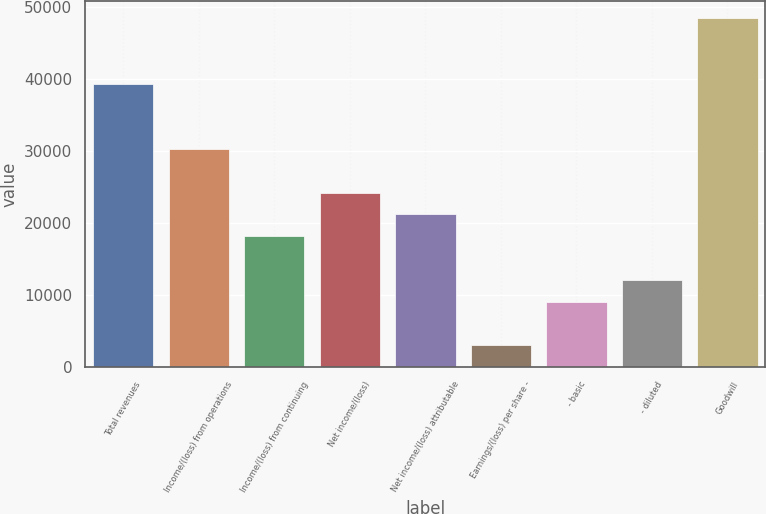Convert chart to OTSL. <chart><loc_0><loc_0><loc_500><loc_500><bar_chart><fcel>Total revenues<fcel>Income/(loss) from operations<fcel>Income/(loss) from continuing<fcel>Net income/(loss)<fcel>Net income/(loss) attributable<fcel>Earnings/(loss) per share -<fcel>- basic<fcel>- diluted<fcel>Goodwill<nl><fcel>39328.3<fcel>30253<fcel>18152.6<fcel>24202.8<fcel>21177.7<fcel>3027.03<fcel>9077.25<fcel>12102.4<fcel>48403.7<nl></chart> 